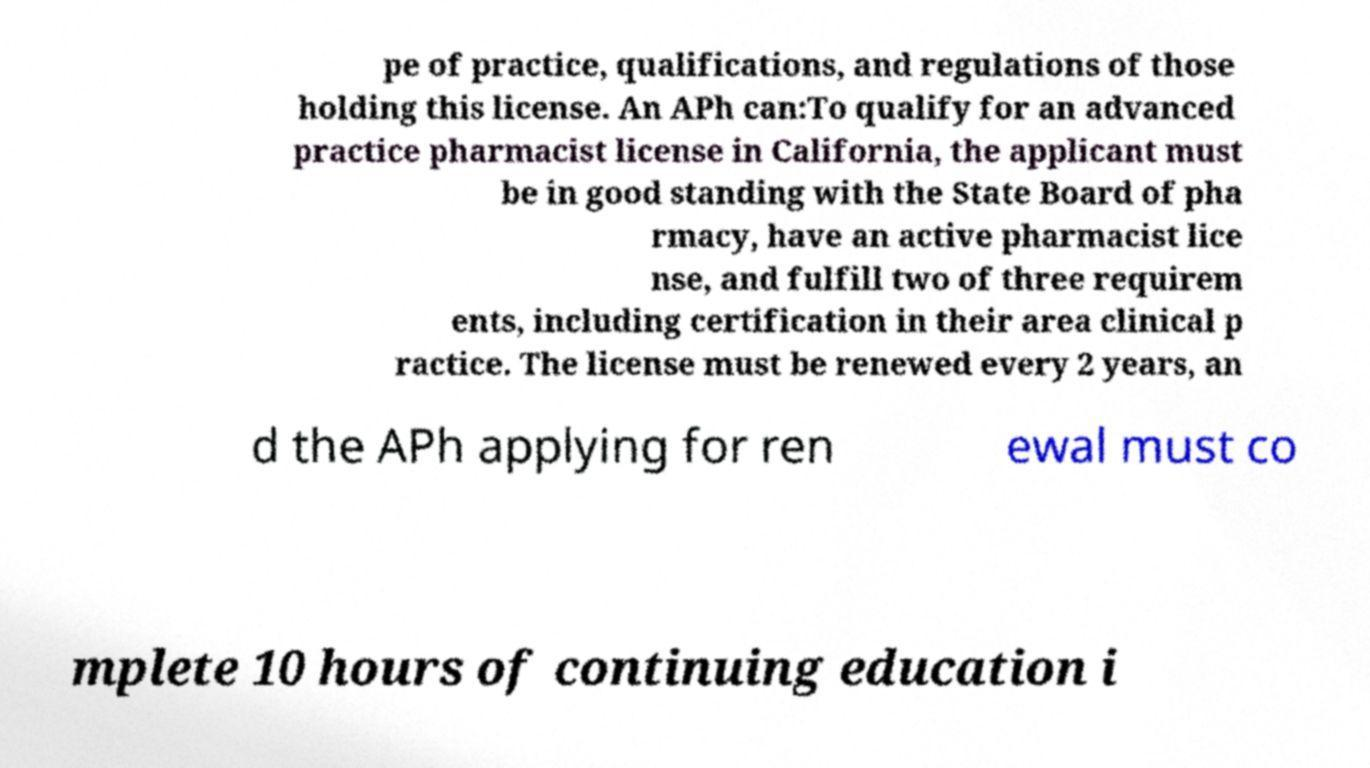I need the written content from this picture converted into text. Can you do that? pe of practice, qualifications, and regulations of those holding this license. An APh can:To qualify for an advanced practice pharmacist license in California, the applicant must be in good standing with the State Board of pha rmacy, have an active pharmacist lice nse, and fulfill two of three requirem ents, including certification in their area clinical p ractice. The license must be renewed every 2 years, an d the APh applying for ren ewal must co mplete 10 hours of continuing education i 